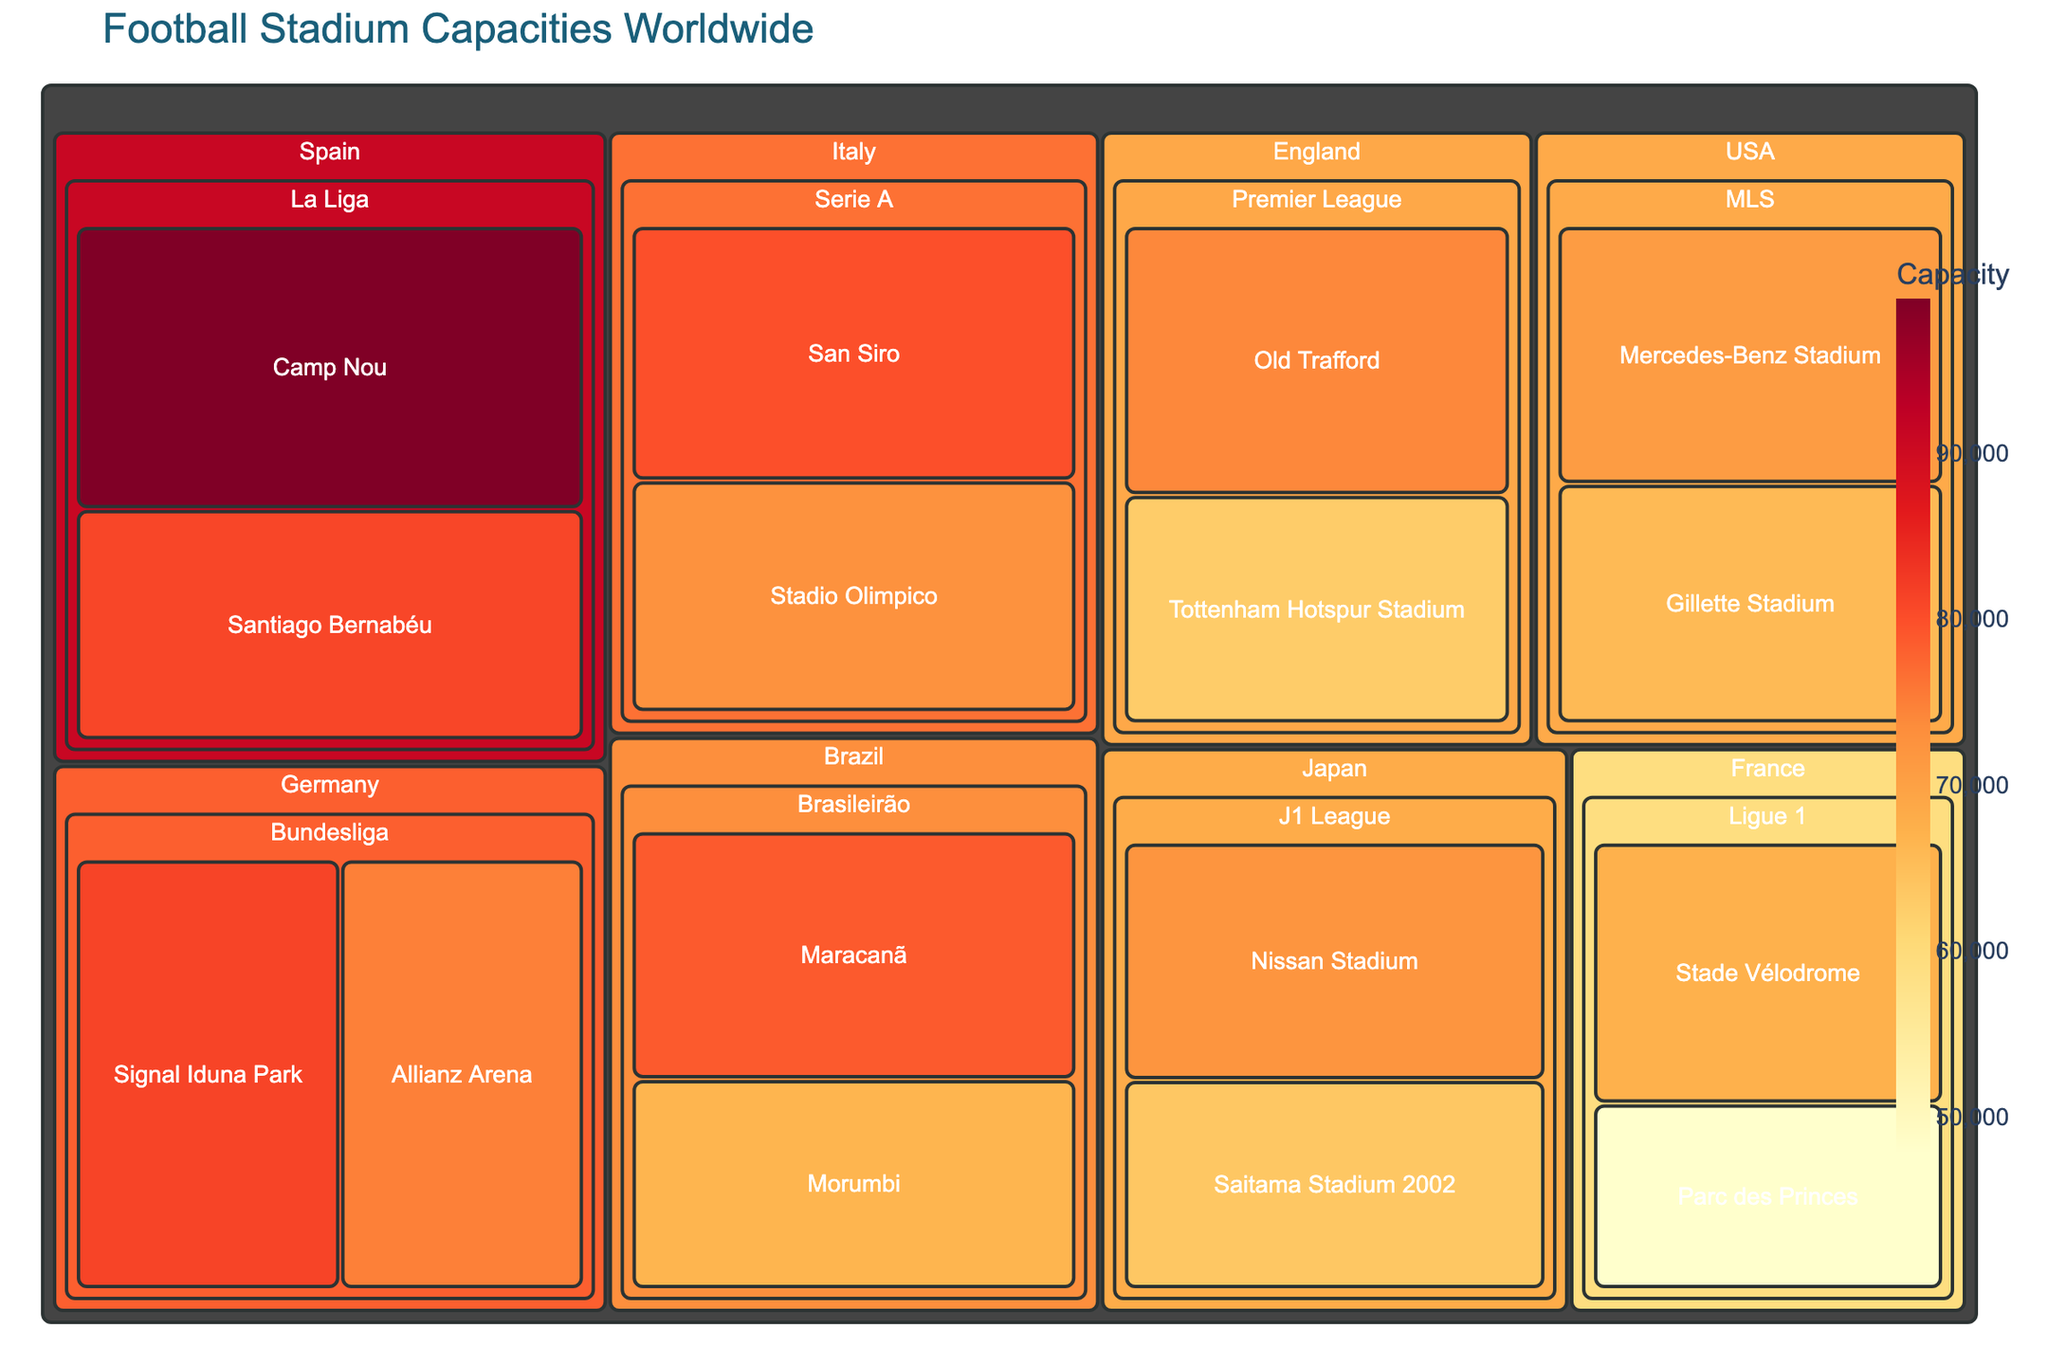what's the title of the chart? The title is usually displayed prominently at the top of the chart to provide a summary of what the chart is about. In this case, it’s mentioned specifically in the code.
Answer: Football Stadium Capacities Worldwide How many leagues are represented in the chart, and which countries have their stadiums showcased? To answer this, look at the hierarchy of the treemap. The first level typically shows the countries, and inside each country are the leagues. Count the unique entries at both levels.
Answer: 8 leagues (Premier League, Bundesliga, La Liga, Serie A, Ligue 1, MLS, Brasileirão, J1 League), from 8 countries (England, Germany, Spain, Italy, France, USA, Brazil, Japan) Which stadium has the largest capacity, and in which country is it located? Treemaps usually represent larger values with larger blocks. To find the stadium with the largest capacity, identify the biggest block.
Answer: Camp Nou in Spain Compare the capacities of the smallest and largest stadiums. What is the difference in their capacities? Identify the smallest and largest blocks, check their capacities, and subtract the smaller capacity from the larger one.
Answer: 99354 - 47929 = 51425 What is the average stadium capacity for the Premier League? Find all the Premier League stadiums, sum their capacities, and divide by the number of those stadiums.
Answer: (74140 + 62850) / 2 = 68495 Which country has the highest total stadium capacity across all its leagues? Sum the capacities of all stadiums within each country and compare the totals.
Answer: Germany How does the capacity of the Mercedes-Benz Stadium compare to that of the Maracanã? Identify the capacities of both stadiums and compare them. Look for which one is greater.
Answer: Mercedes-Benz Stadium is smaller by 71000 - 78838 = 7838 Which league in Europe has the most stadiums listed, and how many do they have? Count the number of stadiums associated with each European league presented (Premier League, Bundesliga, La Liga, Serie A, Ligue 1).
Answer: Premier League, Bundesliga, Serie A, and Ligue 1 all have 2 stadiums each Arrange the stadiums in J1 League by their capacities in descending order. Identify the stadiums within the J1 League and arrange their capacities from highest to lowest.
Answer: Nissan Stadium: 72327, Saitama Stadium 2002: 63700 